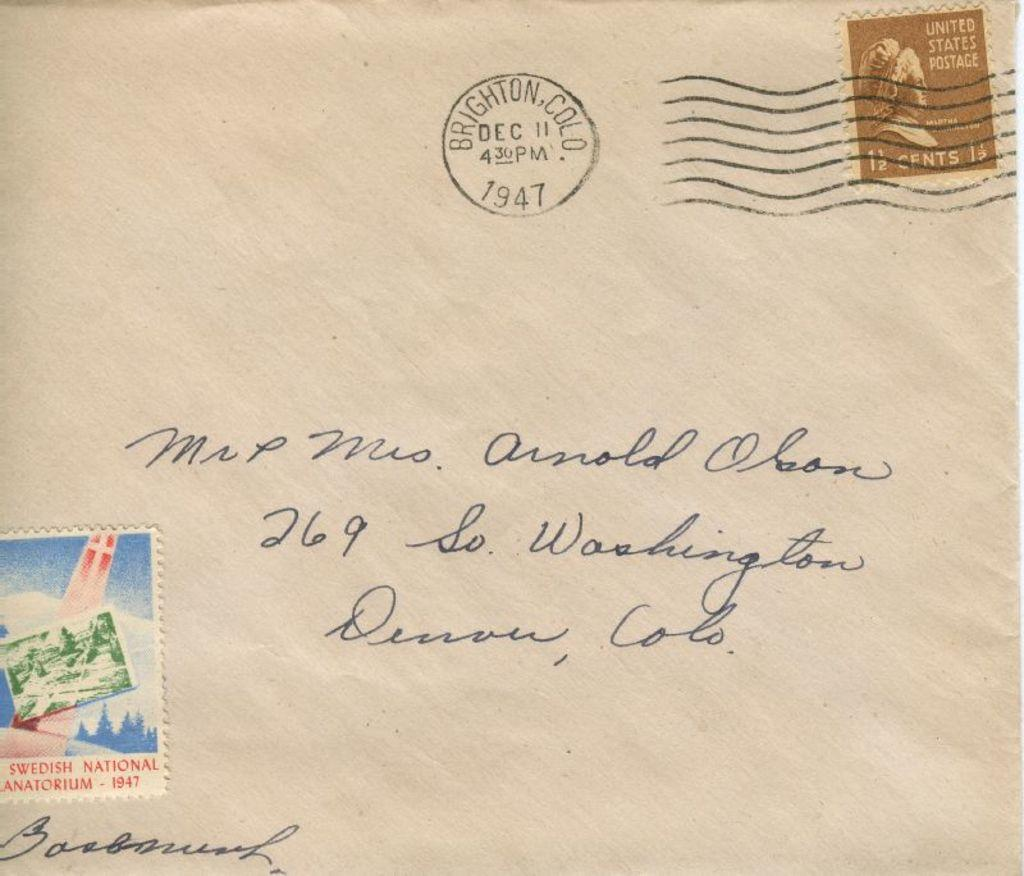Provide a one-sentence caption for the provided image. A letter stamped 1947 is addressed to Mr. and Mrs. Olson. 